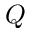<formula> <loc_0><loc_0><loc_500><loc_500>Q</formula> 